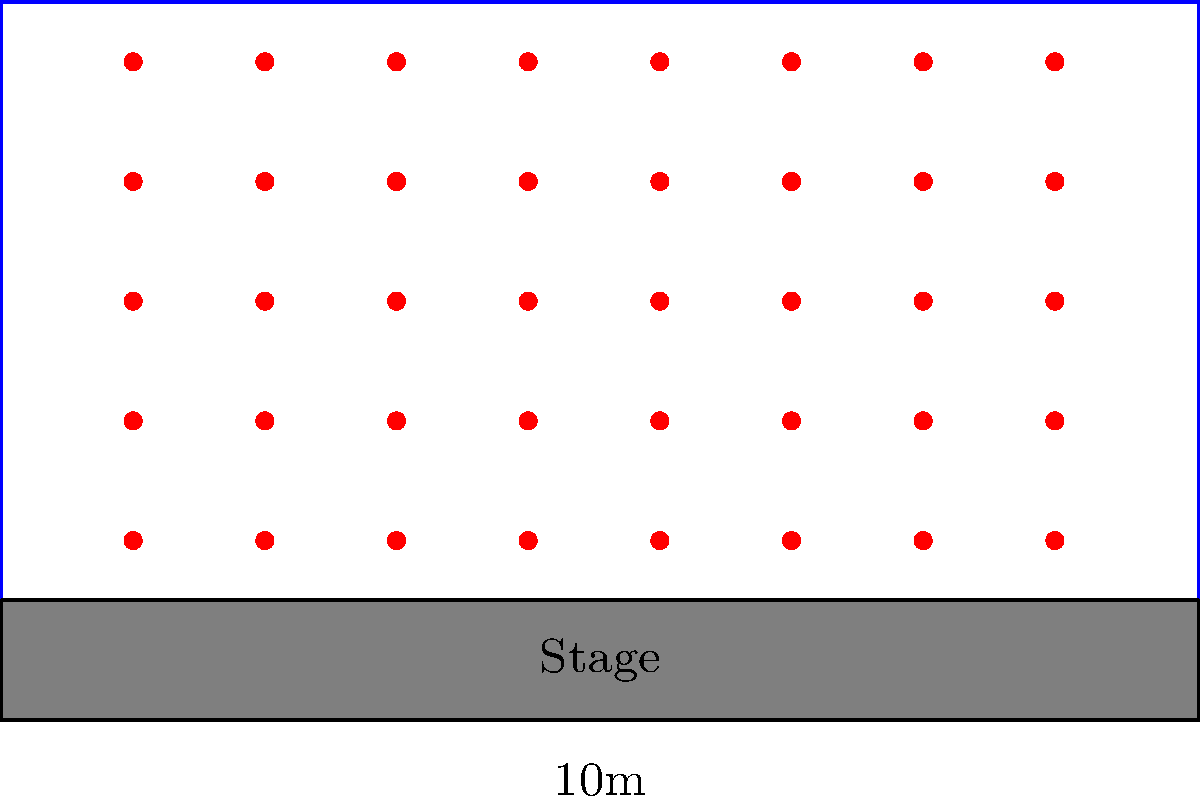A rectangular conference hall measures 10m by 6m, with a 1m deep stage at one end. The organizer wants to maximize seating capacity while ensuring each attendee has a minimum space of 1m² for comfort. How many attendees can be accommodated in this hall? To solve this problem, we'll follow these steps:

1. Calculate the total area of the hall:
   $$ \text{Total Area} = 10\text{m} \times 6\text{m} = 60\text{m}² $$

2. Calculate the area of the stage:
   $$ \text{Stage Area} = 10\text{m} \times 1\text{m} = 10\text{m}² $$

3. Calculate the available seating area:
   $$ \text{Seating Area} = \text{Total Area} - \text{Stage Area} = 60\text{m}² - 10\text{m}² = 50\text{m}² $$

4. Given that each attendee needs 1m² of space, the maximum number of attendees is equal to the seating area:
   $$ \text{Maximum Attendees} = \frac{\text{Seating Area}}{\text{Space per Attendee}} = \frac{50\text{m}²}{1\text{m}²} = 50 $$

Therefore, the conference hall can accommodate a maximum of 50 attendees while ensuring each has 1m² of space.
Answer: 50 attendees 